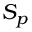<formula> <loc_0><loc_0><loc_500><loc_500>S _ { p }</formula> 